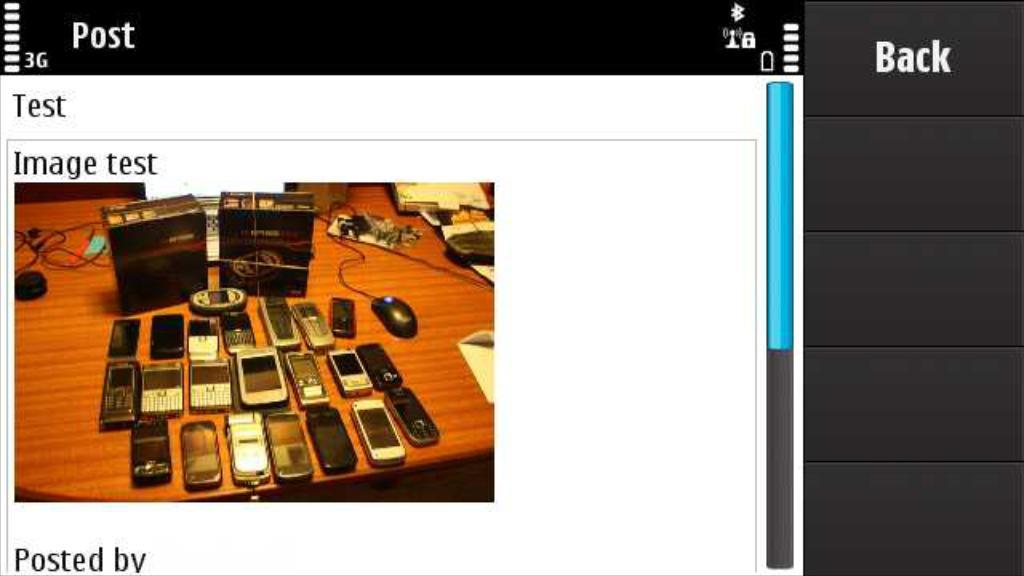<image>
Write a terse but informative summary of the picture. Several cell phones on a table with the words "Image test" above 